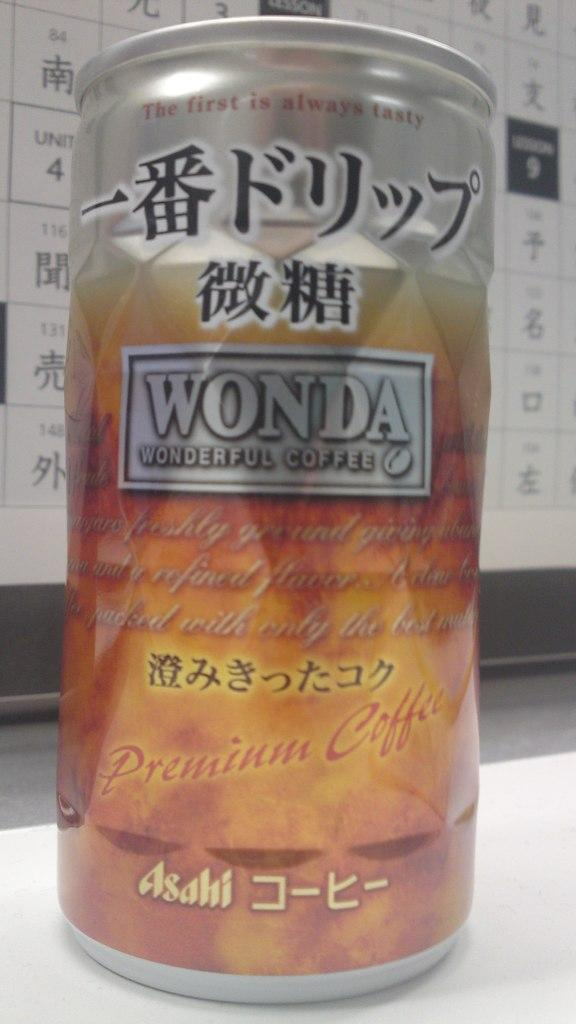What object is present on the white surface in the image? There is a tin on the white surface in the image. What colors can be seen on the tin? The tin has brown and white colors. What can be seen in the background of the image? There is a board in the background of the image. What colors are present on the board? The board has white and black colors. What type of drain is visible in the image? There is no drain present in the image. What committee is meeting in the image? There is no committee meeting in the image; it features a tin on a white surface and a board in the background. 